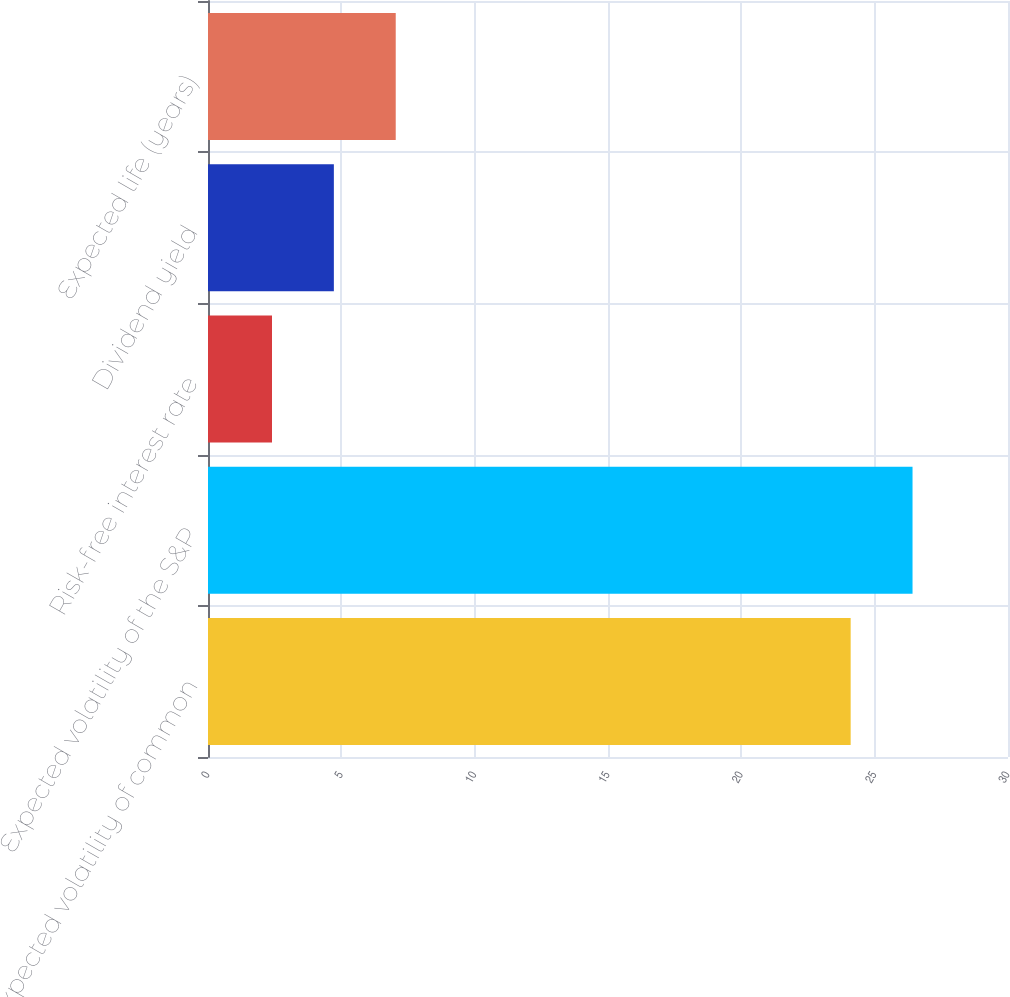Convert chart. <chart><loc_0><loc_0><loc_500><loc_500><bar_chart><fcel>Expected volatility of common<fcel>Expected volatility of the S&P<fcel>Risk-free interest rate<fcel>Dividend yield<fcel>Expected life (years)<nl><fcel>24.1<fcel>26.42<fcel>2.4<fcel>4.72<fcel>7.04<nl></chart> 